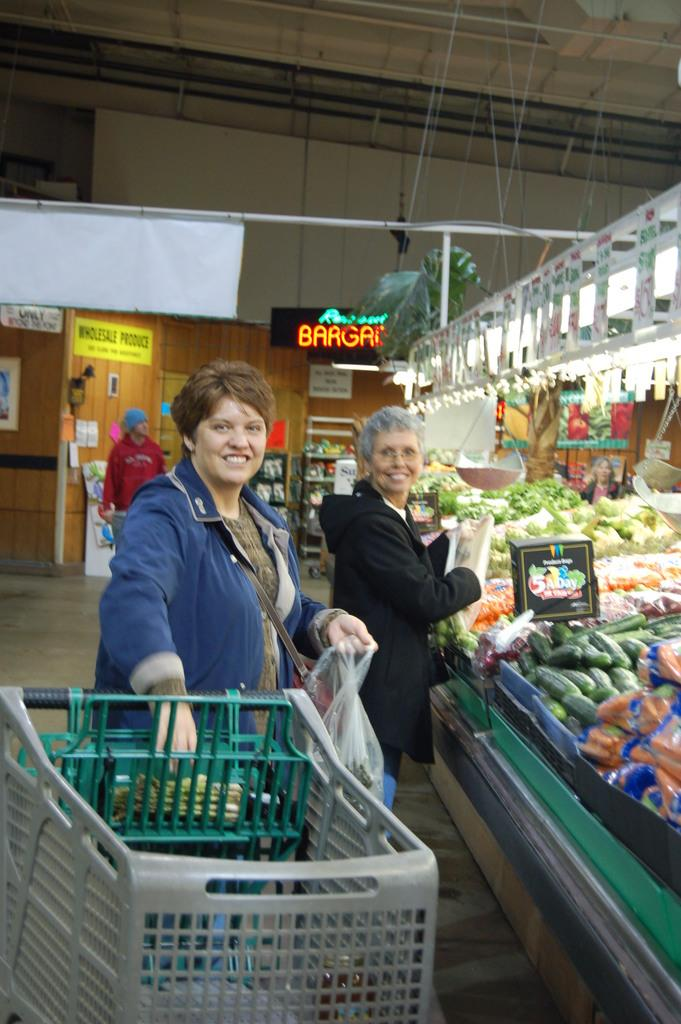<image>
Render a clear and concise summary of the photo. Women smile while buying produce at a store with a sign that reads Wholesale Produce. 